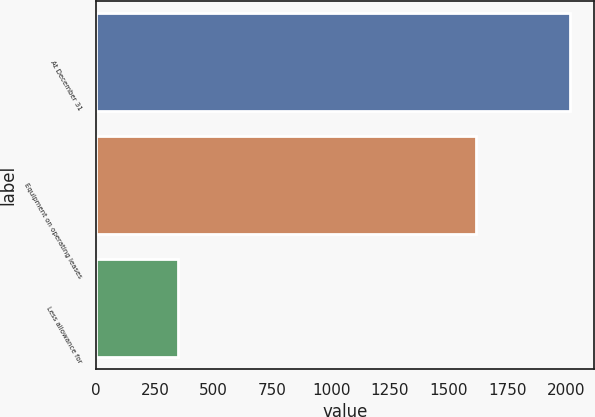<chart> <loc_0><loc_0><loc_500><loc_500><bar_chart><fcel>At December 31<fcel>Equipment on operating leases<fcel>Less allowance for<nl><fcel>2017<fcel>1615.5<fcel>349.8<nl></chart> 